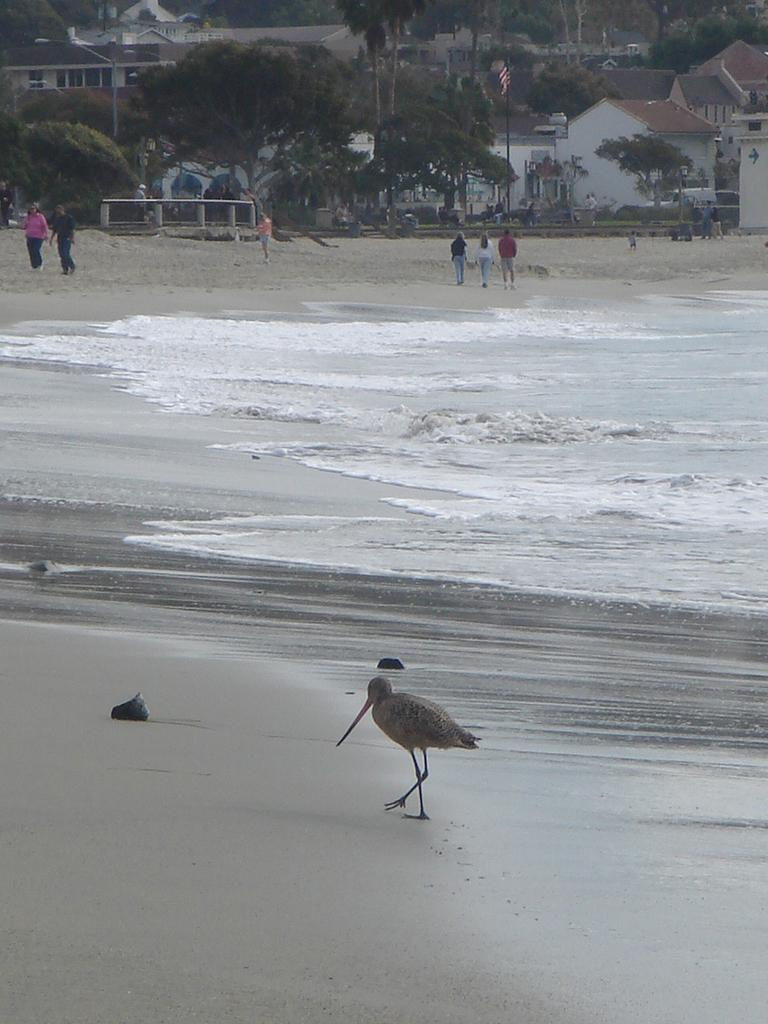What is happening in the image involving people? There are people standing in the image. What type of animal can be seen in the image? There is a bird visible in the image. What is the body of water in the image? There is water in the image. What type of vegetation is present in the image? Trees are present in the image. What type of structures can be seen in the image? There are houses in the image. What type of mine is visible in the image? There is no mine present in the image. What type of board is being used by the people in the image? There is no board visible in the image; the people are simply standing. 